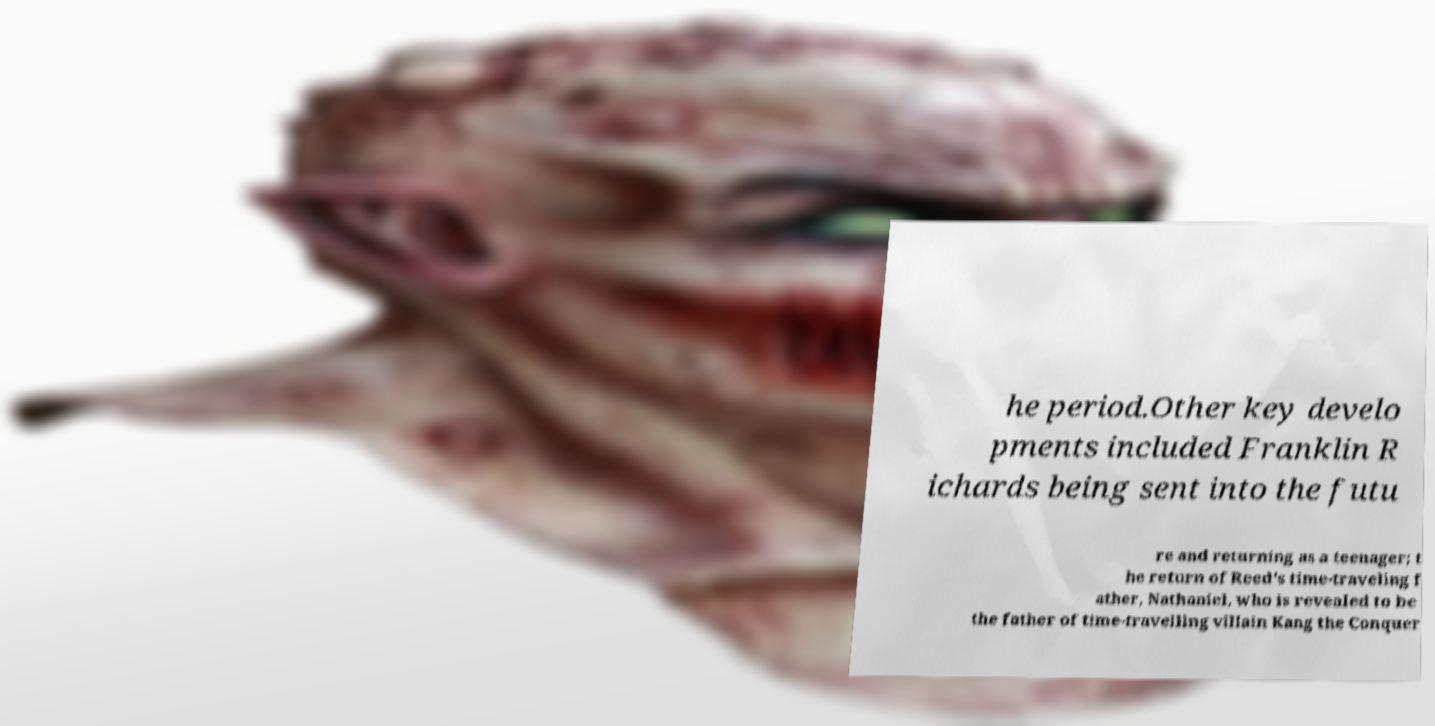Could you extract and type out the text from this image? he period.Other key develo pments included Franklin R ichards being sent into the futu re and returning as a teenager; t he return of Reed's time-traveling f ather, Nathaniel, who is revealed to be the father of time-travelling villain Kang the Conquer 